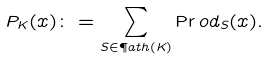Convert formula to latex. <formula><loc_0><loc_0><loc_500><loc_500>P _ { K } ( x ) \colon = \sum _ { S \in \P a t h ( K ) } \Pr o d _ { S } ( x ) .</formula> 